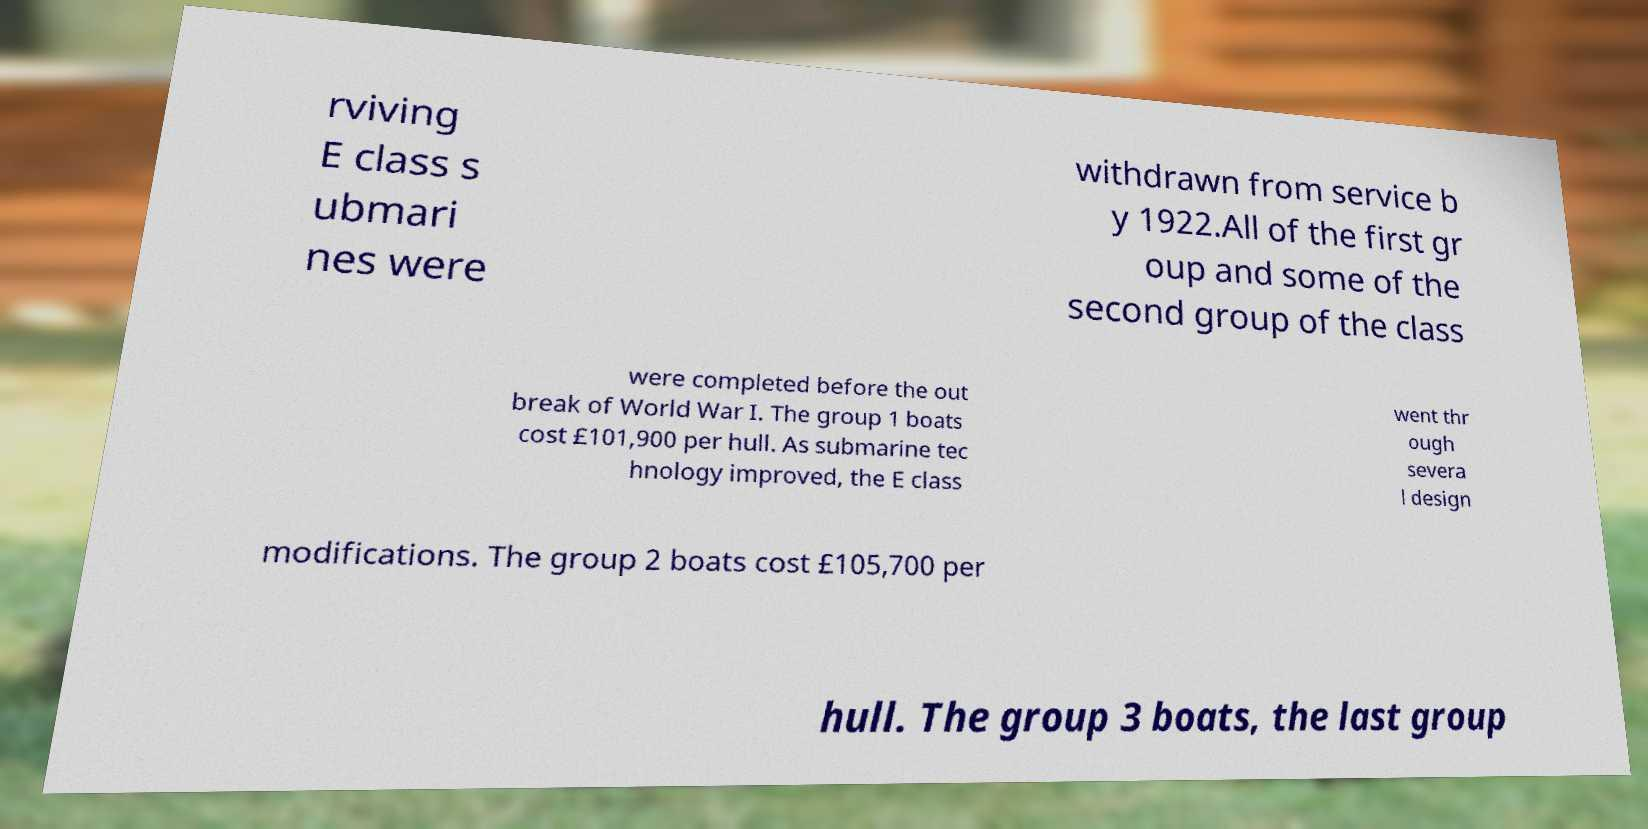For documentation purposes, I need the text within this image transcribed. Could you provide that? rviving E class s ubmari nes were withdrawn from service b y 1922.All of the first gr oup and some of the second group of the class were completed before the out break of World War I. The group 1 boats cost £101,900 per hull. As submarine tec hnology improved, the E class went thr ough severa l design modifications. The group 2 boats cost £105,700 per hull. The group 3 boats, the last group 